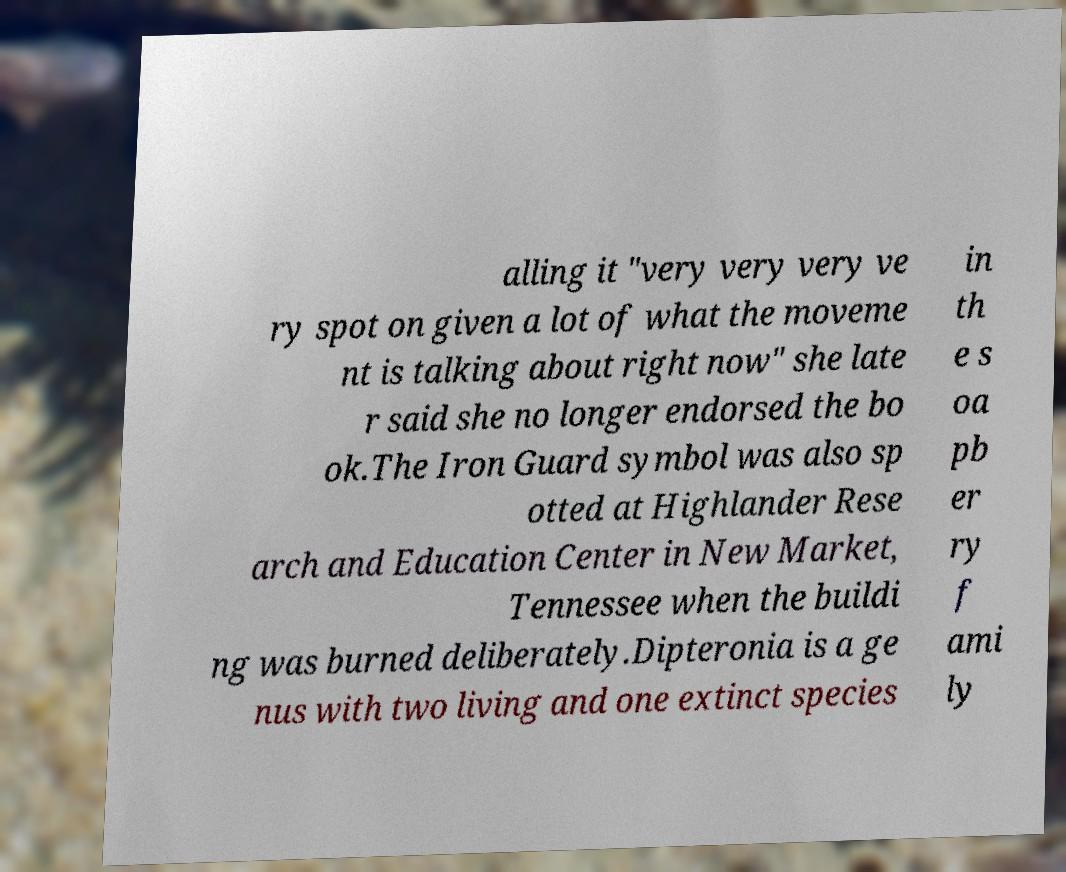Could you assist in decoding the text presented in this image and type it out clearly? alling it "very very very ve ry spot on given a lot of what the moveme nt is talking about right now" she late r said she no longer endorsed the bo ok.The Iron Guard symbol was also sp otted at Highlander Rese arch and Education Center in New Market, Tennessee when the buildi ng was burned deliberately.Dipteronia is a ge nus with two living and one extinct species in th e s oa pb er ry f ami ly 